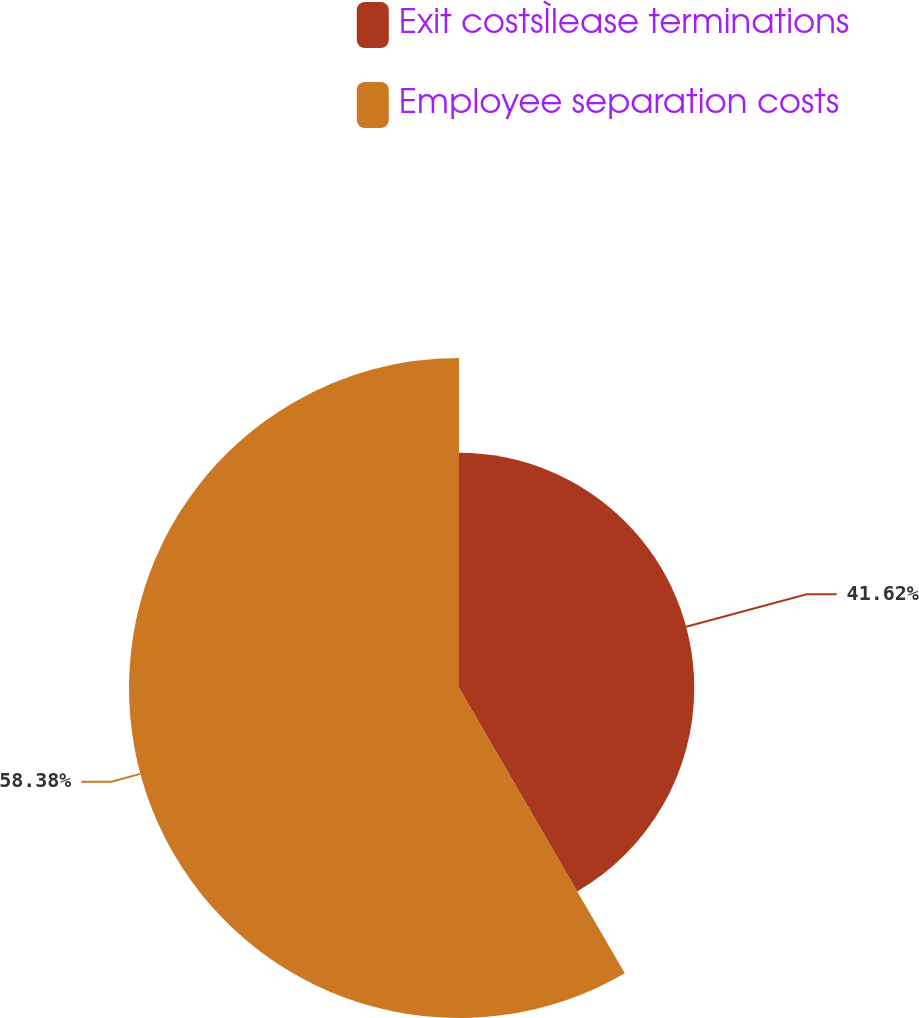Convert chart to OTSL. <chart><loc_0><loc_0><loc_500><loc_500><pie_chart><fcel>Exit costsÌlease terminations<fcel>Employee separation costs<nl><fcel>41.62%<fcel>58.38%<nl></chart> 